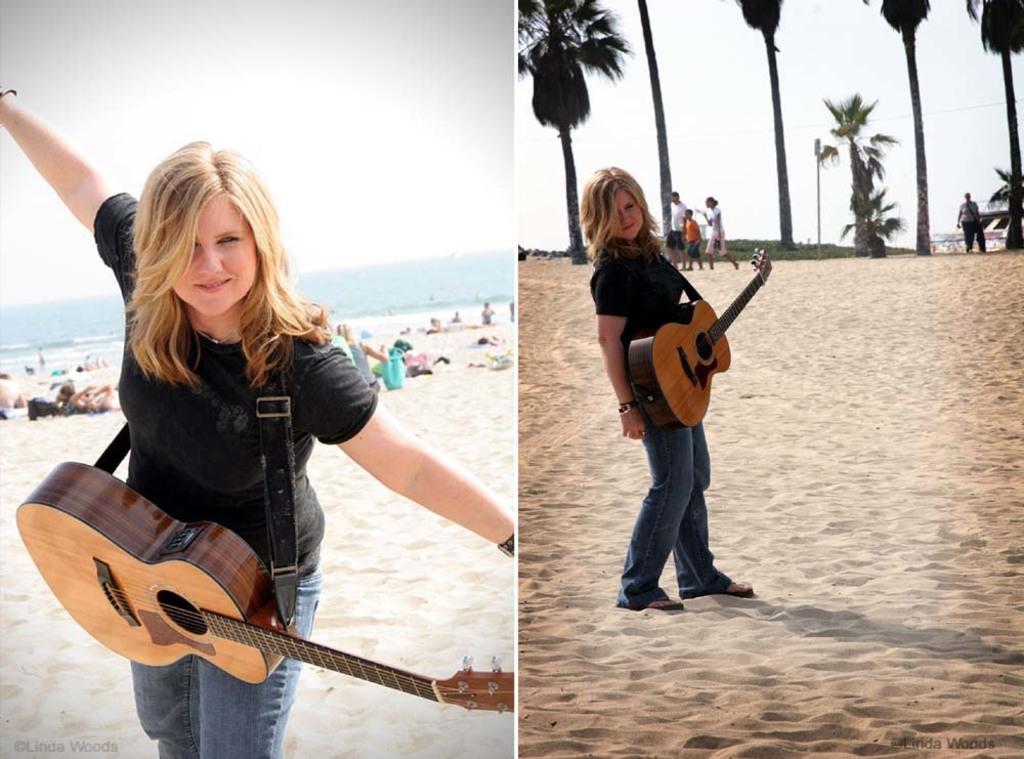In one or two sentences, can you explain what this image depicts? A woman is posing to camera wearing a guitar. She is at a beach. She wears a black T shirt and denim pant. There is a sea in the background. The sky is clear. 